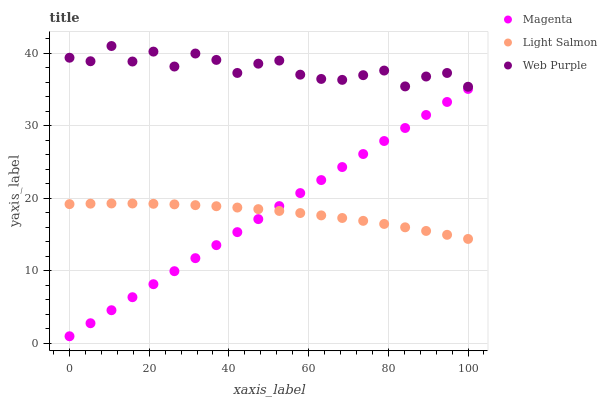Does Light Salmon have the minimum area under the curve?
Answer yes or no. Yes. Does Web Purple have the maximum area under the curve?
Answer yes or no. Yes. Does Magenta have the minimum area under the curve?
Answer yes or no. No. Does Magenta have the maximum area under the curve?
Answer yes or no. No. Is Magenta the smoothest?
Answer yes or no. Yes. Is Web Purple the roughest?
Answer yes or no. Yes. Is Light Salmon the smoothest?
Answer yes or no. No. Is Light Salmon the roughest?
Answer yes or no. No. Does Magenta have the lowest value?
Answer yes or no. Yes. Does Light Salmon have the lowest value?
Answer yes or no. No. Does Web Purple have the highest value?
Answer yes or no. Yes. Does Magenta have the highest value?
Answer yes or no. No. Is Magenta less than Web Purple?
Answer yes or no. Yes. Is Web Purple greater than Magenta?
Answer yes or no. Yes. Does Light Salmon intersect Magenta?
Answer yes or no. Yes. Is Light Salmon less than Magenta?
Answer yes or no. No. Is Light Salmon greater than Magenta?
Answer yes or no. No. Does Magenta intersect Web Purple?
Answer yes or no. No. 